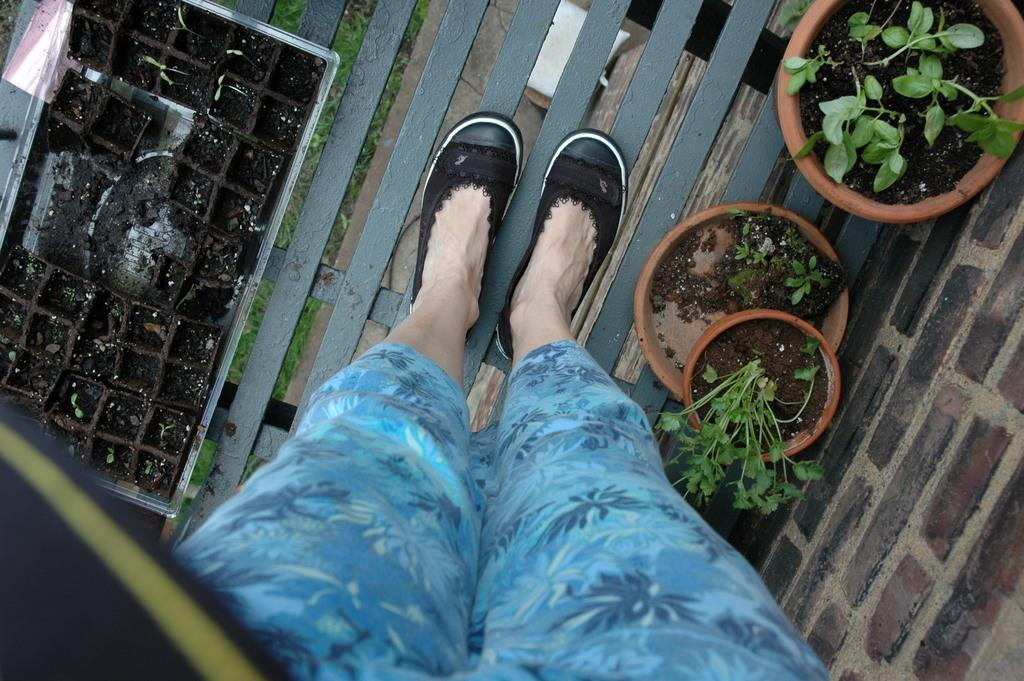What can be seen at the bottom of the image? There are legs of a person in the image. What type of vegetation is present in the image? There are plants in flower pots in the image. What hobbies does the ant have in the image? There are no ants present in the image, so it is not possible to determine their hobbies. 